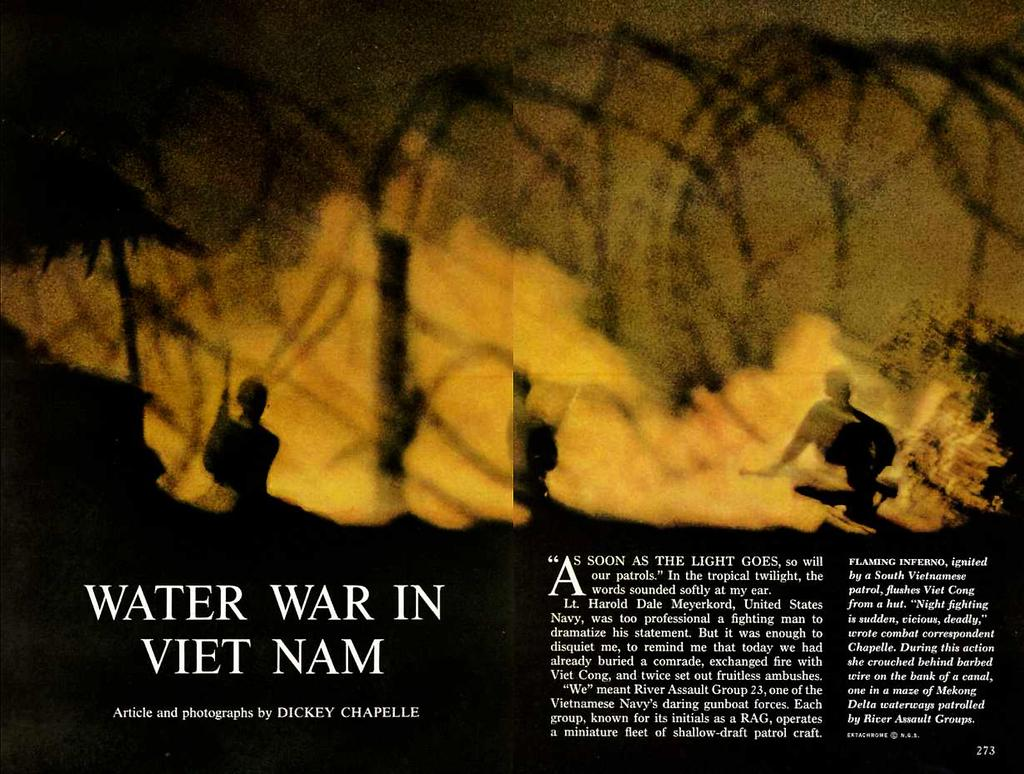<image>
Offer a succinct explanation of the picture presented. An article by Dickey Chapelle shows a picture of a fire. 